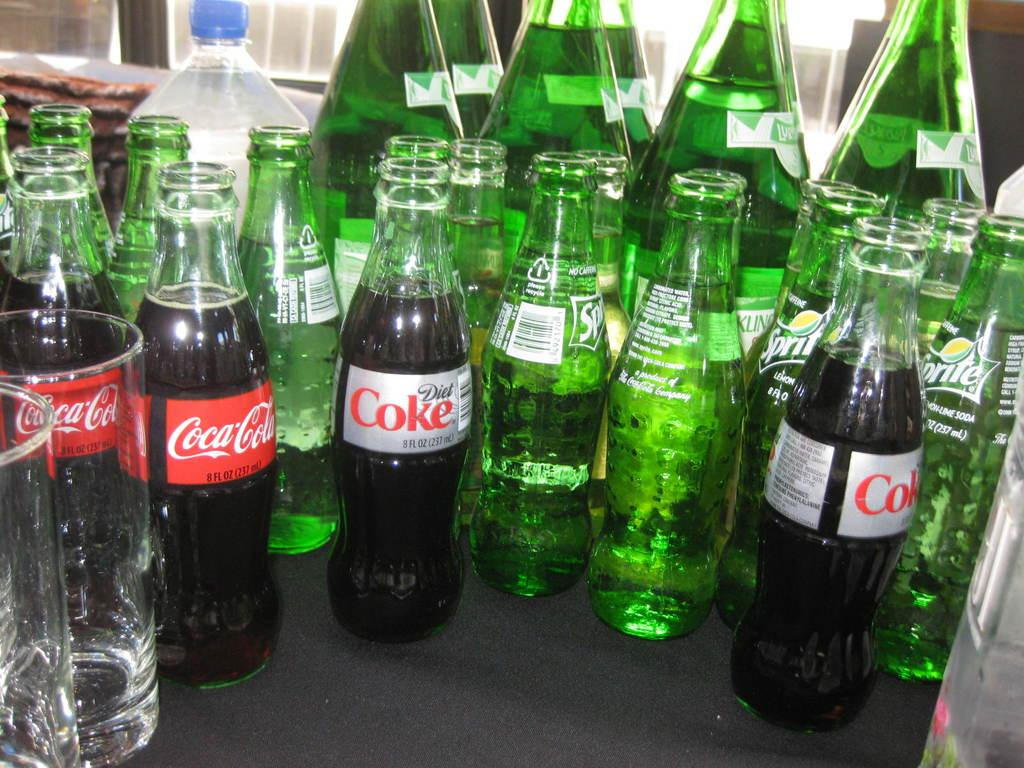What types of beverages can be seen in the image? There are different kinds of drinks in the image. Where are the bottles located in the image? The bottles are on the table in the image. How many glasses are visible on the left side of the image? There are two glasses on the left side of the image. Can you see any yaks walking on the trail in the image? There are no yaks or trails present in the image; it features drinks, bottles, and glasses. 